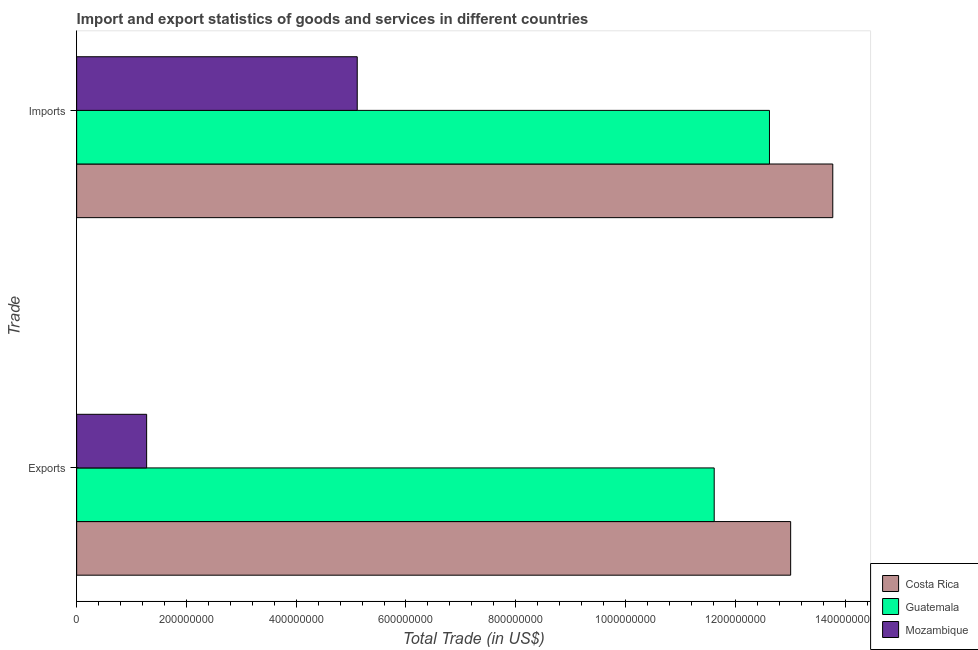How many groups of bars are there?
Keep it short and to the point. 2. Are the number of bars per tick equal to the number of legend labels?
Your response must be concise. Yes. How many bars are there on the 2nd tick from the top?
Offer a terse response. 3. How many bars are there on the 1st tick from the bottom?
Keep it short and to the point. 3. What is the label of the 2nd group of bars from the top?
Give a very brief answer. Exports. What is the export of goods and services in Mozambique?
Provide a succinct answer. 1.27e+08. Across all countries, what is the maximum export of goods and services?
Ensure brevity in your answer.  1.30e+09. Across all countries, what is the minimum imports of goods and services?
Keep it short and to the point. 5.11e+08. In which country was the export of goods and services maximum?
Your response must be concise. Costa Rica. In which country was the imports of goods and services minimum?
Your answer should be very brief. Mozambique. What is the total export of goods and services in the graph?
Offer a terse response. 2.59e+09. What is the difference between the export of goods and services in Costa Rica and that in Mozambique?
Your answer should be very brief. 1.17e+09. What is the difference between the imports of goods and services in Guatemala and the export of goods and services in Mozambique?
Ensure brevity in your answer.  1.13e+09. What is the average imports of goods and services per country?
Your answer should be compact. 1.05e+09. What is the difference between the export of goods and services and imports of goods and services in Costa Rica?
Keep it short and to the point. -7.68e+07. What is the ratio of the imports of goods and services in Mozambique to that in Costa Rica?
Your response must be concise. 0.37. In how many countries, is the export of goods and services greater than the average export of goods and services taken over all countries?
Keep it short and to the point. 2. What does the 1st bar from the top in Exports represents?
Offer a terse response. Mozambique. How many countries are there in the graph?
Ensure brevity in your answer.  3. What is the difference between two consecutive major ticks on the X-axis?
Ensure brevity in your answer.  2.00e+08. Does the graph contain any zero values?
Offer a terse response. No. Where does the legend appear in the graph?
Give a very brief answer. Bottom right. How many legend labels are there?
Your response must be concise. 3. What is the title of the graph?
Offer a terse response. Import and export statistics of goods and services in different countries. What is the label or title of the X-axis?
Your response must be concise. Total Trade (in US$). What is the label or title of the Y-axis?
Ensure brevity in your answer.  Trade. What is the Total Trade (in US$) in Costa Rica in Exports?
Provide a short and direct response. 1.30e+09. What is the Total Trade (in US$) in Guatemala in Exports?
Your answer should be compact. 1.16e+09. What is the Total Trade (in US$) of Mozambique in Exports?
Give a very brief answer. 1.27e+08. What is the Total Trade (in US$) in Costa Rica in Imports?
Provide a short and direct response. 1.38e+09. What is the Total Trade (in US$) of Guatemala in Imports?
Provide a short and direct response. 1.26e+09. What is the Total Trade (in US$) in Mozambique in Imports?
Give a very brief answer. 5.11e+08. Across all Trade, what is the maximum Total Trade (in US$) in Costa Rica?
Ensure brevity in your answer.  1.38e+09. Across all Trade, what is the maximum Total Trade (in US$) in Guatemala?
Your answer should be very brief. 1.26e+09. Across all Trade, what is the maximum Total Trade (in US$) in Mozambique?
Your answer should be very brief. 5.11e+08. Across all Trade, what is the minimum Total Trade (in US$) of Costa Rica?
Provide a succinct answer. 1.30e+09. Across all Trade, what is the minimum Total Trade (in US$) of Guatemala?
Give a very brief answer. 1.16e+09. Across all Trade, what is the minimum Total Trade (in US$) of Mozambique?
Ensure brevity in your answer.  1.27e+08. What is the total Total Trade (in US$) of Costa Rica in the graph?
Ensure brevity in your answer.  2.68e+09. What is the total Total Trade (in US$) of Guatemala in the graph?
Give a very brief answer. 2.42e+09. What is the total Total Trade (in US$) in Mozambique in the graph?
Your answer should be very brief. 6.39e+08. What is the difference between the Total Trade (in US$) of Costa Rica in Exports and that in Imports?
Your answer should be compact. -7.68e+07. What is the difference between the Total Trade (in US$) in Guatemala in Exports and that in Imports?
Provide a short and direct response. -1.01e+08. What is the difference between the Total Trade (in US$) in Mozambique in Exports and that in Imports?
Ensure brevity in your answer.  -3.84e+08. What is the difference between the Total Trade (in US$) of Costa Rica in Exports and the Total Trade (in US$) of Guatemala in Imports?
Provide a succinct answer. 3.86e+07. What is the difference between the Total Trade (in US$) in Costa Rica in Exports and the Total Trade (in US$) in Mozambique in Imports?
Give a very brief answer. 7.90e+08. What is the difference between the Total Trade (in US$) of Guatemala in Exports and the Total Trade (in US$) of Mozambique in Imports?
Give a very brief answer. 6.50e+08. What is the average Total Trade (in US$) in Costa Rica per Trade?
Make the answer very short. 1.34e+09. What is the average Total Trade (in US$) in Guatemala per Trade?
Make the answer very short. 1.21e+09. What is the average Total Trade (in US$) of Mozambique per Trade?
Make the answer very short. 3.19e+08. What is the difference between the Total Trade (in US$) of Costa Rica and Total Trade (in US$) of Guatemala in Exports?
Give a very brief answer. 1.39e+08. What is the difference between the Total Trade (in US$) of Costa Rica and Total Trade (in US$) of Mozambique in Exports?
Ensure brevity in your answer.  1.17e+09. What is the difference between the Total Trade (in US$) of Guatemala and Total Trade (in US$) of Mozambique in Exports?
Your response must be concise. 1.03e+09. What is the difference between the Total Trade (in US$) of Costa Rica and Total Trade (in US$) of Guatemala in Imports?
Provide a short and direct response. 1.15e+08. What is the difference between the Total Trade (in US$) of Costa Rica and Total Trade (in US$) of Mozambique in Imports?
Keep it short and to the point. 8.66e+08. What is the difference between the Total Trade (in US$) in Guatemala and Total Trade (in US$) in Mozambique in Imports?
Your answer should be compact. 7.51e+08. What is the ratio of the Total Trade (in US$) in Costa Rica in Exports to that in Imports?
Your answer should be very brief. 0.94. What is the ratio of the Total Trade (in US$) in Guatemala in Exports to that in Imports?
Give a very brief answer. 0.92. What is the ratio of the Total Trade (in US$) of Mozambique in Exports to that in Imports?
Make the answer very short. 0.25. What is the difference between the highest and the second highest Total Trade (in US$) of Costa Rica?
Your answer should be compact. 7.68e+07. What is the difference between the highest and the second highest Total Trade (in US$) in Guatemala?
Offer a very short reply. 1.01e+08. What is the difference between the highest and the second highest Total Trade (in US$) of Mozambique?
Ensure brevity in your answer.  3.84e+08. What is the difference between the highest and the lowest Total Trade (in US$) in Costa Rica?
Provide a succinct answer. 7.68e+07. What is the difference between the highest and the lowest Total Trade (in US$) of Guatemala?
Your response must be concise. 1.01e+08. What is the difference between the highest and the lowest Total Trade (in US$) in Mozambique?
Make the answer very short. 3.84e+08. 